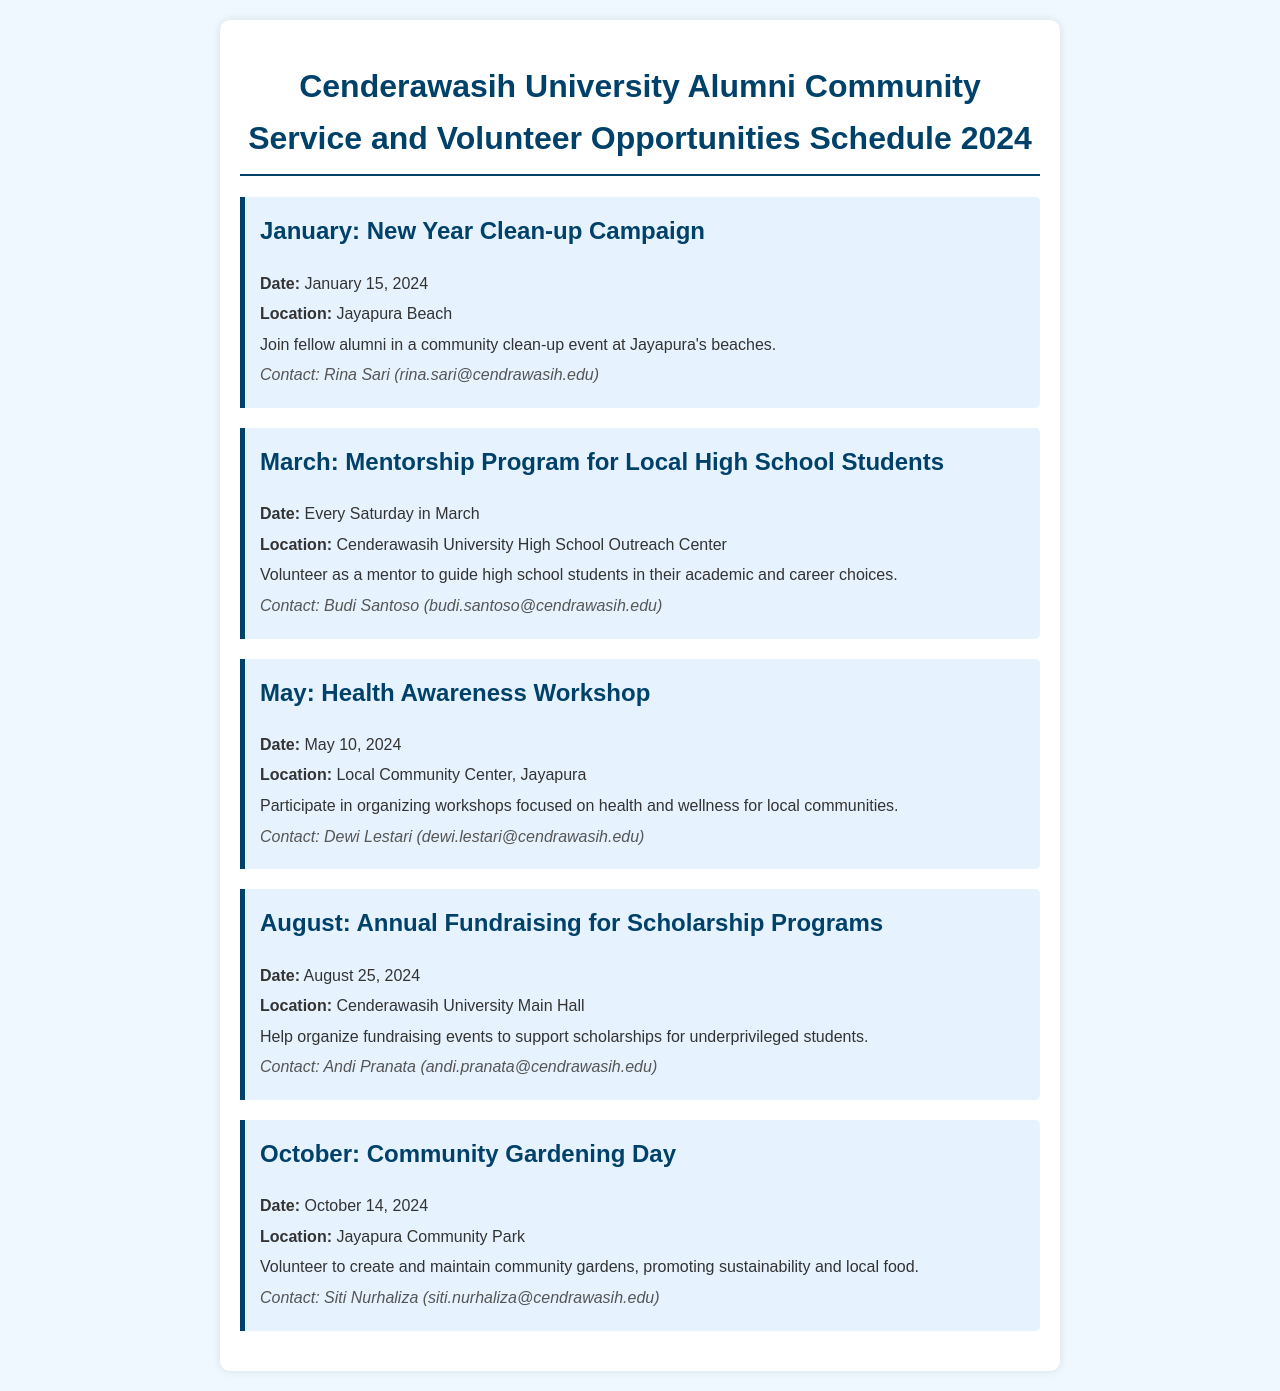What is the first community service event of the year? The document lists the New Year Clean-up Campaign as the first event scheduled for January.
Answer: New Year Clean-up Campaign When is the Health Awareness Workshop scheduled? According to the document, the Health Awareness Workshop is set for May 10, 2024.
Answer: May 10, 2024 Who can be contacted for the Mentorship Program? The documentation provides the name and email of the contact person for the Mentorship Program.
Answer: Budi Santoso (budi.santoso@cendrawasih.edu) Where will the Annual Fundraising for Scholarship Programs take place? The document specifies the location for the fundraising event to be at Cenderawasih University Main Hall.
Answer: Cenderawasih University Main Hall How many days does the Mentorship Program occur in March? The document indicates that the Mentorship Program will take place every Saturday in March, which totals to 5 Saturdays.
Answer: 5 What theme is focused on during October’s community service initiative? The document states that the theme for October's initiative is community gardening.
Answer: Community Gardening Which month features the New Year Clean-up Campaign? The document mentions the New Year Clean-up Campaign occurring in January.
Answer: January Who should be contacted for the Community Gardening Day? The document provides contact information for the person managing the Community Gardening Day.
Answer: Siti Nurhaliza (siti.nurhaliza@cendrawasih.edu) 